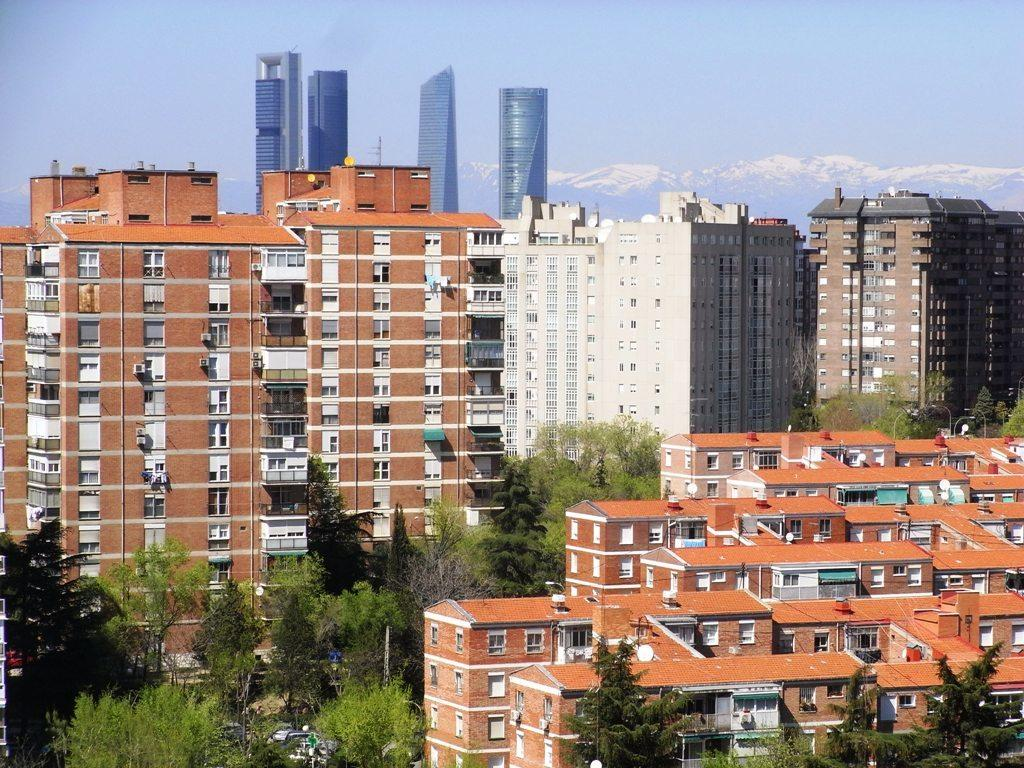What can be seen in the background of the image? There is a sky visible in the background of the image, along with huge buildings. What type of structures are present in the image? There are buildings present in the image. What other natural elements can be seen in the image? There are trees in the image. What rule does the man in the image need to follow? There is no man present in the image, so there is no rule to follow. 